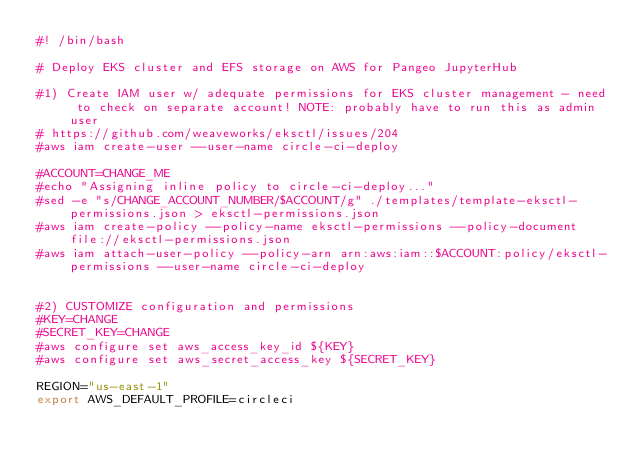Convert code to text. <code><loc_0><loc_0><loc_500><loc_500><_Bash_>#! /bin/bash

# Deploy EKS cluster and EFS storage on AWS for Pangeo JupyterHub

#1) Create IAM user w/ adequate permissions for EKS cluster management - need to check on separate account! NOTE: probably have to run this as admin user
# https://github.com/weaveworks/eksctl/issues/204
#aws iam create-user --user-name circle-ci-deploy

#ACCOUNT=CHANGE_ME
#echo "Assigning inline policy to circle-ci-deploy..."
#sed -e "s/CHANGE_ACCOUNT_NUMBER/$ACCOUNT/g" ./templates/template-eksctl-permissions.json > eksctl-permissions.json
#aws iam create-policy --policy-name eksctl-permissions --policy-document file://eksctl-permissions.json
#aws iam attach-user-policy --policy-arn arn:aws:iam::$ACCOUNT:policy/eksctl-permissions --user-name circle-ci-deploy


#2) CUSTOMIZE configuration and permissions
#KEY=CHANGE
#SECRET_KEY=CHANGE
#aws configure set aws_access_key_id ${KEY}
#aws configure set aws_secret_access_key ${SECRET_KEY}

REGION="us-east-1"
export AWS_DEFAULT_PROFILE=circleci</code> 